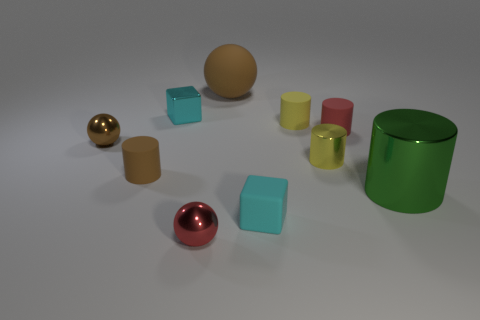Are there any other things that are the same size as the brown shiny ball?
Offer a very short reply. Yes. What number of tiny red objects are on the left side of the brown rubber cylinder?
Offer a terse response. 0. There is a large thing that is on the right side of the small yellow cylinder that is in front of the brown shiny object; what shape is it?
Make the answer very short. Cylinder. Is there any other thing that has the same shape as the red metal thing?
Make the answer very short. Yes. Is the number of tiny yellow metallic cylinders that are behind the yellow rubber object greater than the number of cyan cylinders?
Give a very brief answer. No. There is a brown matte thing that is in front of the red matte cylinder; how many tiny metal things are to the right of it?
Provide a succinct answer. 3. The cyan object in front of the big thing that is in front of the matte object that is on the right side of the small yellow shiny object is what shape?
Ensure brevity in your answer.  Cube. The metal cube is what size?
Your response must be concise. Small. Are there any tiny cyan things made of the same material as the small brown ball?
Provide a succinct answer. Yes. There is a yellow metal thing that is the same shape as the small yellow matte object; what size is it?
Ensure brevity in your answer.  Small. 